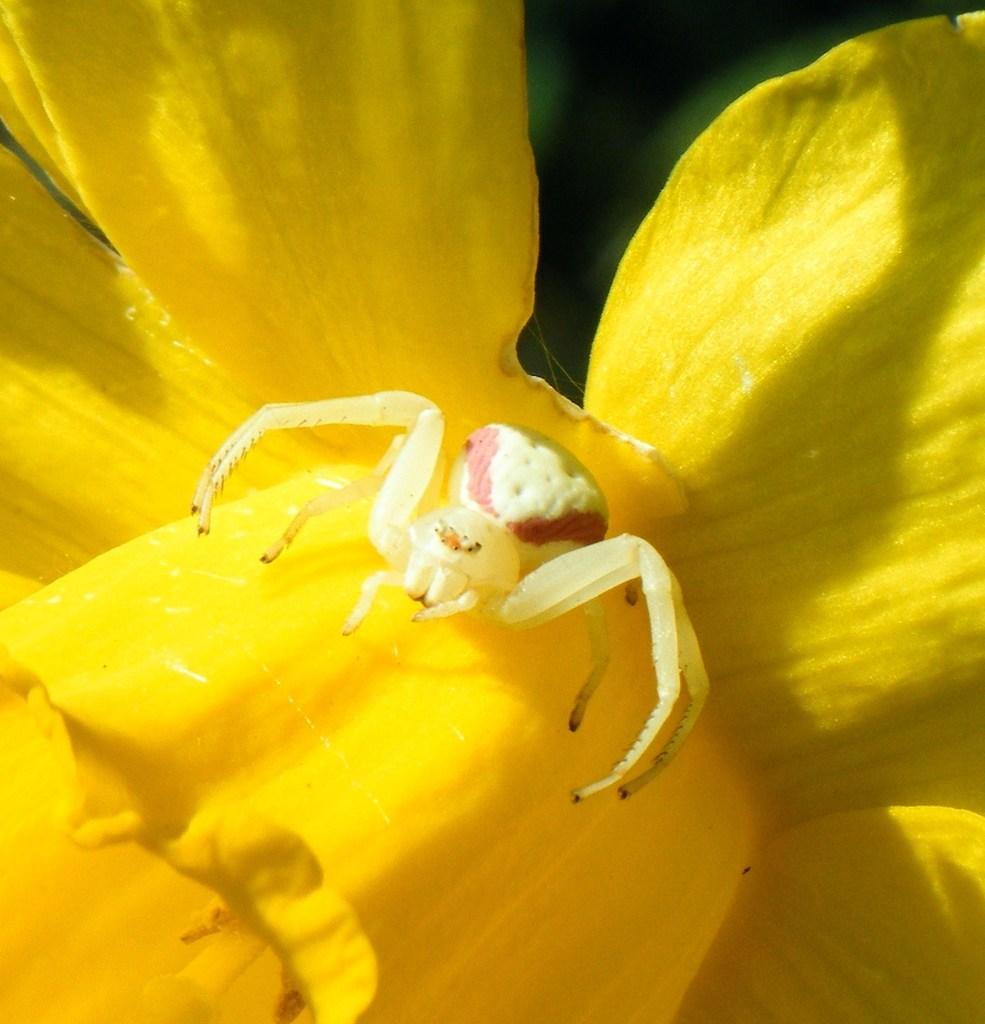What is the color of the spider in the picture? The spider is white in color. What is the spider sitting on in the picture? The spider is on a flower. What is the color of the flower the spider is on? The flower is yellow in color. How many clocks can be seen in the picture? There are no clocks present in the picture; it features a white spider on a yellow flower. What type of chess piece is the spider holding in the picture? There is no chess piece present in the picture; the spider is simply sitting on a flower. 